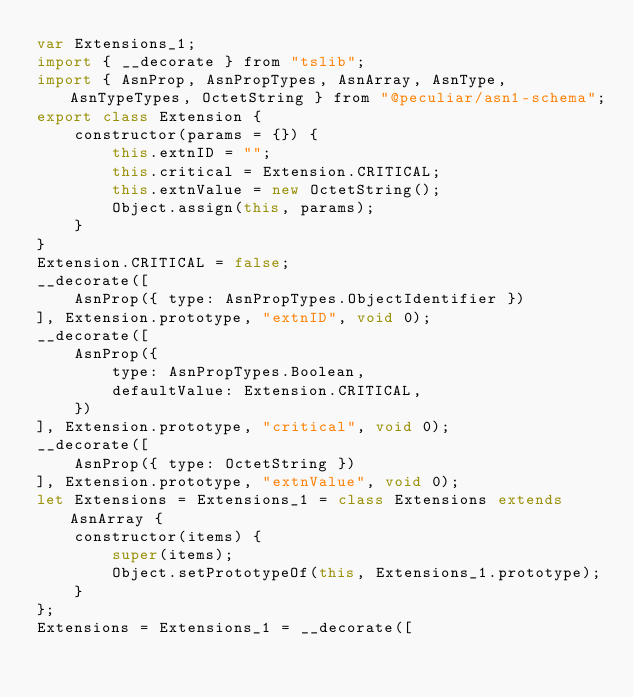<code> <loc_0><loc_0><loc_500><loc_500><_JavaScript_>var Extensions_1;
import { __decorate } from "tslib";
import { AsnProp, AsnPropTypes, AsnArray, AsnType, AsnTypeTypes, OctetString } from "@peculiar/asn1-schema";
export class Extension {
    constructor(params = {}) {
        this.extnID = "";
        this.critical = Extension.CRITICAL;
        this.extnValue = new OctetString();
        Object.assign(this, params);
    }
}
Extension.CRITICAL = false;
__decorate([
    AsnProp({ type: AsnPropTypes.ObjectIdentifier })
], Extension.prototype, "extnID", void 0);
__decorate([
    AsnProp({
        type: AsnPropTypes.Boolean,
        defaultValue: Extension.CRITICAL,
    })
], Extension.prototype, "critical", void 0);
__decorate([
    AsnProp({ type: OctetString })
], Extension.prototype, "extnValue", void 0);
let Extensions = Extensions_1 = class Extensions extends AsnArray {
    constructor(items) {
        super(items);
        Object.setPrototypeOf(this, Extensions_1.prototype);
    }
};
Extensions = Extensions_1 = __decorate([</code> 